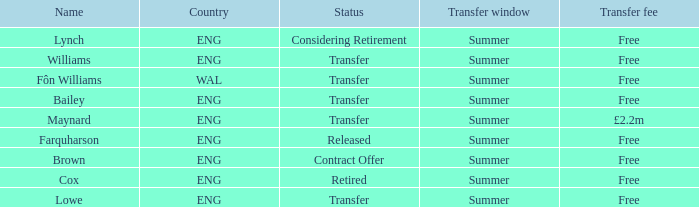What is the designation of the no-cost transfer fee with a transfer situation and an eng territory? Bailey, Williams, Lowe. 